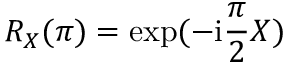Convert formula to latex. <formula><loc_0><loc_0><loc_500><loc_500>R _ { X } ( \pi ) = \exp ( - i \frac { \pi } { 2 } X )</formula> 